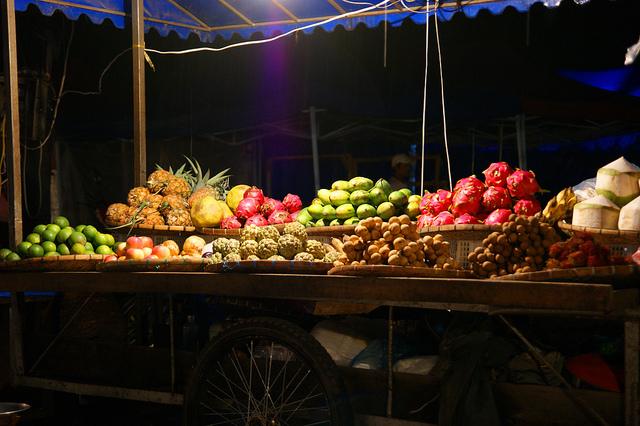What is he selling?
Concise answer only. Fruit. Are this all pineapples?
Short answer required. No. What fruit is being sold?
Quick response, please. Tropical fruit. What types of fruit are shown?
Keep it brief. Tropical. Are there pineapples on the table?
Quick response, please. Yes. 